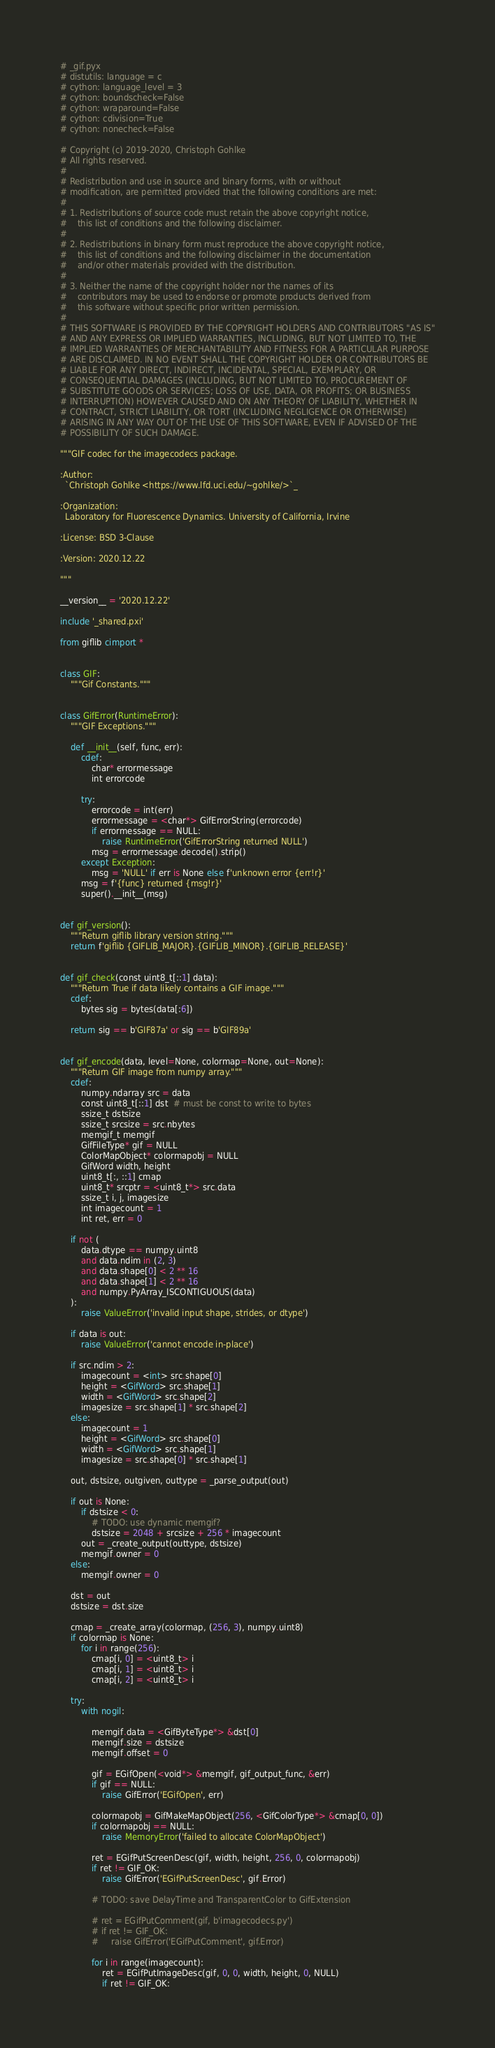Convert code to text. <code><loc_0><loc_0><loc_500><loc_500><_Cython_># _gif.pyx
# distutils: language = c
# cython: language_level = 3
# cython: boundscheck=False
# cython: wraparound=False
# cython: cdivision=True
# cython: nonecheck=False

# Copyright (c) 2019-2020, Christoph Gohlke
# All rights reserved.
#
# Redistribution and use in source and binary forms, with or without
# modification, are permitted provided that the following conditions are met:
#
# 1. Redistributions of source code must retain the above copyright notice,
#    this list of conditions and the following disclaimer.
#
# 2. Redistributions in binary form must reproduce the above copyright notice,
#    this list of conditions and the following disclaimer in the documentation
#    and/or other materials provided with the distribution.
#
# 3. Neither the name of the copyright holder nor the names of its
#    contributors may be used to endorse or promote products derived from
#    this software without specific prior written permission.
#
# THIS SOFTWARE IS PROVIDED BY THE COPYRIGHT HOLDERS AND CONTRIBUTORS "AS IS"
# AND ANY EXPRESS OR IMPLIED WARRANTIES, INCLUDING, BUT NOT LIMITED TO, THE
# IMPLIED WARRANTIES OF MERCHANTABILITY AND FITNESS FOR A PARTICULAR PURPOSE
# ARE DISCLAIMED. IN NO EVENT SHALL THE COPYRIGHT HOLDER OR CONTRIBUTORS BE
# LIABLE FOR ANY DIRECT, INDIRECT, INCIDENTAL, SPECIAL, EXEMPLARY, OR
# CONSEQUENTIAL DAMAGES (INCLUDING, BUT NOT LIMITED TO, PROCUREMENT OF
# SUBSTITUTE GOODS OR SERVICES; LOSS OF USE, DATA, OR PROFITS; OR BUSINESS
# INTERRUPTION) HOWEVER CAUSED AND ON ANY THEORY OF LIABILITY, WHETHER IN
# CONTRACT, STRICT LIABILITY, OR TORT (INCLUDING NEGLIGENCE OR OTHERWISE)
# ARISING IN ANY WAY OUT OF THE USE OF THIS SOFTWARE, EVEN IF ADVISED OF THE
# POSSIBILITY OF SUCH DAMAGE.

"""GIF codec for the imagecodecs package.

:Author:
  `Christoph Gohlke <https://www.lfd.uci.edu/~gohlke/>`_

:Organization:
  Laboratory for Fluorescence Dynamics. University of California, Irvine

:License: BSD 3-Clause

:Version: 2020.12.22

"""

__version__ = '2020.12.22'

include '_shared.pxi'

from giflib cimport *


class GIF:
    """Gif Constants."""


class GifError(RuntimeError):
    """GIF Exceptions."""

    def __init__(self, func, err):
        cdef:
            char* errormessage
            int errorcode

        try:
            errorcode = int(err)
            errormessage = <char*> GifErrorString(errorcode)
            if errormessage == NULL:
                raise RuntimeError('GifErrorString returned NULL')
            msg = errormessage.decode().strip()
        except Exception:
            msg = 'NULL' if err is None else f'unknown error {err!r}'
        msg = f'{func} returned {msg!r}'
        super().__init__(msg)


def gif_version():
    """Return giflib library version string."""
    return f'giflib {GIFLIB_MAJOR}.{GIFLIB_MINOR}.{GIFLIB_RELEASE}'


def gif_check(const uint8_t[::1] data):
    """Return True if data likely contains a GIF image."""
    cdef:
        bytes sig = bytes(data[:6])

    return sig == b'GIF87a' or sig == b'GIF89a'


def gif_encode(data, level=None, colormap=None, out=None):
    """Return GIF image from numpy array."""
    cdef:
        numpy.ndarray src = data
        const uint8_t[::1] dst  # must be const to write to bytes
        ssize_t dstsize
        ssize_t srcsize = src.nbytes
        memgif_t memgif
        GifFileType* gif = NULL
        ColorMapObject* colormapobj = NULL
        GifWord width, height
        uint8_t[:, ::1] cmap
        uint8_t* srcptr = <uint8_t*> src.data
        ssize_t i, j, imagesize
        int imagecount = 1
        int ret, err = 0

    if not (
        data.dtype == numpy.uint8
        and data.ndim in (2, 3)
        and data.shape[0] < 2 ** 16
        and data.shape[1] < 2 ** 16
        and numpy.PyArray_ISCONTIGUOUS(data)
    ):
        raise ValueError('invalid input shape, strides, or dtype')

    if data is out:
        raise ValueError('cannot encode in-place')

    if src.ndim > 2:
        imagecount = <int> src.shape[0]
        height = <GifWord> src.shape[1]
        width = <GifWord> src.shape[2]
        imagesize = src.shape[1] * src.shape[2]
    else:
        imagecount = 1
        height = <GifWord> src.shape[0]
        width = <GifWord> src.shape[1]
        imagesize = src.shape[0] * src.shape[1]

    out, dstsize, outgiven, outtype = _parse_output(out)

    if out is None:
        if dstsize < 0:
            # TODO: use dynamic memgif?
            dstsize = 2048 + srcsize + 256 * imagecount
        out = _create_output(outtype, dstsize)
        memgif.owner = 0
    else:
        memgif.owner = 0

    dst = out
    dstsize = dst.size

    cmap = _create_array(colormap, (256, 3), numpy.uint8)
    if colormap is None:
        for i in range(256):
            cmap[i, 0] = <uint8_t> i
            cmap[i, 1] = <uint8_t> i
            cmap[i, 2] = <uint8_t> i

    try:
        with nogil:

            memgif.data = <GifByteType*> &dst[0]
            memgif.size = dstsize
            memgif.offset = 0

            gif = EGifOpen(<void*> &memgif, gif_output_func, &err)
            if gif == NULL:
                raise GifError('EGifOpen', err)

            colormapobj = GifMakeMapObject(256, <GifColorType*> &cmap[0, 0])
            if colormapobj == NULL:
                raise MemoryError('failed to allocate ColorMapObject')

            ret = EGifPutScreenDesc(gif, width, height, 256, 0, colormapobj)
            if ret != GIF_OK:
                raise GifError('EGifPutScreenDesc', gif.Error)

            # TODO: save DelayTime and TransparentColor to GifExtension

            # ret = EGifPutComment(gif, b'imagecodecs.py')
            # if ret != GIF_OK:
            #     raise GifError('EGifPutComment', gif.Error)

            for i in range(imagecount):
                ret = EGifPutImageDesc(gif, 0, 0, width, height, 0, NULL)
                if ret != GIF_OK:</code> 